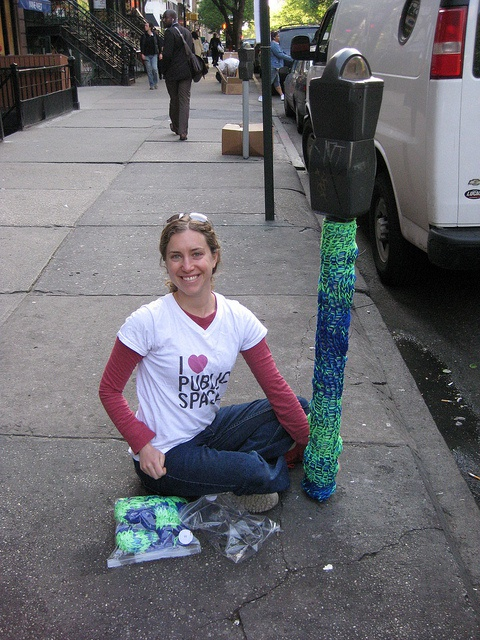Describe the objects in this image and their specific colors. I can see people in black, lavender, and gray tones, truck in black, darkgray, and gray tones, car in black, darkgray, and gray tones, parking meter in black, gray, and white tones, and people in black, gray, and darkgray tones in this image. 